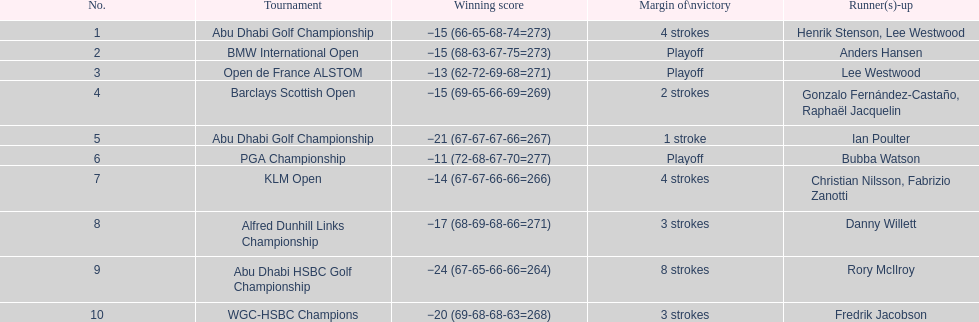How many winning scores were less than -14? 2. 